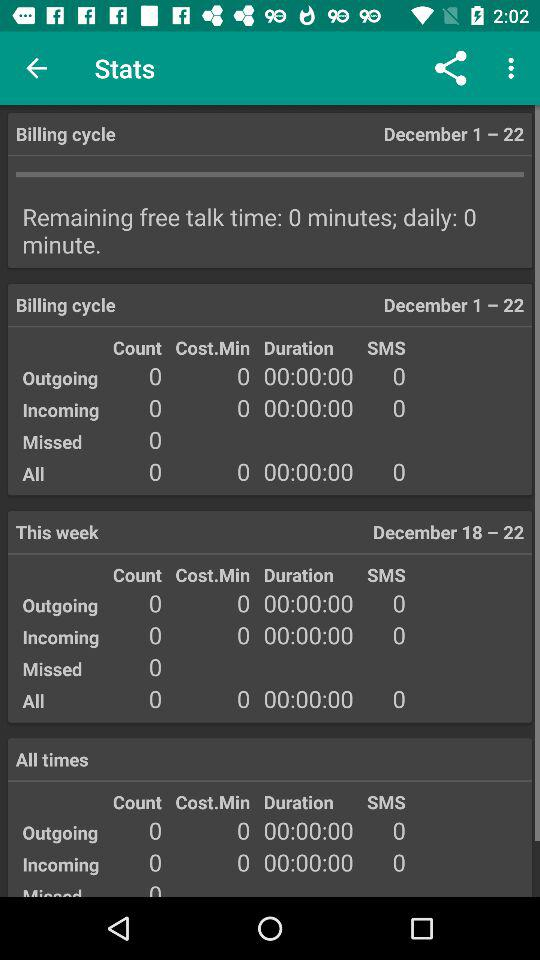What is the date of the billing cycle? The dates of the billing cycle are from December 1 to December 22. 